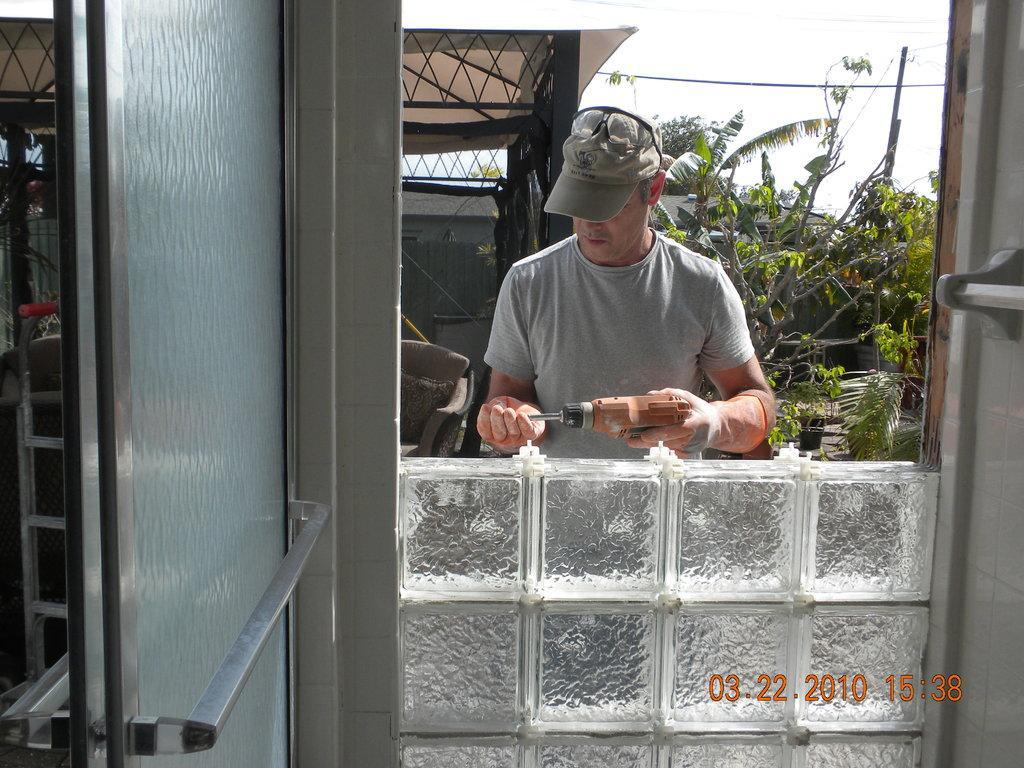In one or two sentences, can you explain what this image depicts? In this picture there is a man in the center of the image, by holding a tool in his hand and there is a door on the left side of the image and there is a roof and trees in the background area of the image and there are glass bricks at the bottom side of the image. 